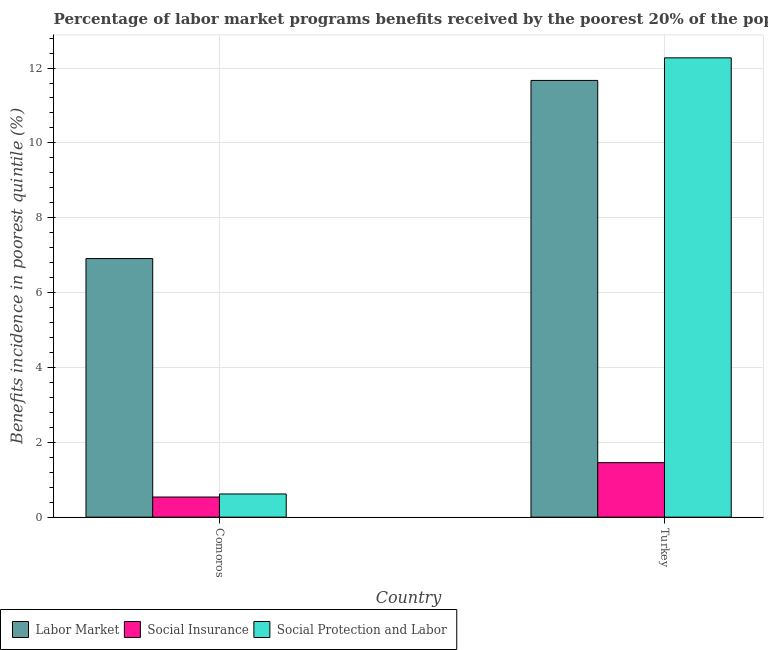How many different coloured bars are there?
Your response must be concise. 3. How many groups of bars are there?
Ensure brevity in your answer.  2. Are the number of bars on each tick of the X-axis equal?
Your response must be concise. Yes. How many bars are there on the 2nd tick from the left?
Your response must be concise. 3. How many bars are there on the 2nd tick from the right?
Keep it short and to the point. 3. What is the label of the 1st group of bars from the left?
Provide a succinct answer. Comoros. In how many cases, is the number of bars for a given country not equal to the number of legend labels?
Provide a short and direct response. 0. What is the percentage of benefits received due to labor market programs in Turkey?
Your response must be concise. 11.67. Across all countries, what is the maximum percentage of benefits received due to social insurance programs?
Make the answer very short. 1.46. Across all countries, what is the minimum percentage of benefits received due to social protection programs?
Your response must be concise. 0.62. In which country was the percentage of benefits received due to labor market programs maximum?
Keep it short and to the point. Turkey. In which country was the percentage of benefits received due to social protection programs minimum?
Provide a short and direct response. Comoros. What is the total percentage of benefits received due to labor market programs in the graph?
Give a very brief answer. 18.58. What is the difference between the percentage of benefits received due to labor market programs in Comoros and that in Turkey?
Offer a terse response. -4.76. What is the difference between the percentage of benefits received due to labor market programs in Comoros and the percentage of benefits received due to social protection programs in Turkey?
Your answer should be very brief. -5.36. What is the average percentage of benefits received due to social insurance programs per country?
Keep it short and to the point. 1. What is the difference between the percentage of benefits received due to social insurance programs and percentage of benefits received due to social protection programs in Comoros?
Offer a terse response. -0.08. What is the ratio of the percentage of benefits received due to social protection programs in Comoros to that in Turkey?
Offer a very short reply. 0.05. In how many countries, is the percentage of benefits received due to social insurance programs greater than the average percentage of benefits received due to social insurance programs taken over all countries?
Your response must be concise. 1. What does the 1st bar from the left in Turkey represents?
Your response must be concise. Labor Market. What does the 3rd bar from the right in Turkey represents?
Offer a terse response. Labor Market. Is it the case that in every country, the sum of the percentage of benefits received due to labor market programs and percentage of benefits received due to social insurance programs is greater than the percentage of benefits received due to social protection programs?
Make the answer very short. Yes. How many countries are there in the graph?
Your response must be concise. 2. Are the values on the major ticks of Y-axis written in scientific E-notation?
Provide a succinct answer. No. Does the graph contain any zero values?
Provide a short and direct response. No. How many legend labels are there?
Ensure brevity in your answer.  3. How are the legend labels stacked?
Ensure brevity in your answer.  Horizontal. What is the title of the graph?
Give a very brief answer. Percentage of labor market programs benefits received by the poorest 20% of the population of countries. Does "Hydroelectric sources" appear as one of the legend labels in the graph?
Your response must be concise. No. What is the label or title of the X-axis?
Make the answer very short. Country. What is the label or title of the Y-axis?
Give a very brief answer. Benefits incidence in poorest quintile (%). What is the Benefits incidence in poorest quintile (%) of Labor Market in Comoros?
Your answer should be very brief. 6.91. What is the Benefits incidence in poorest quintile (%) of Social Insurance in Comoros?
Offer a very short reply. 0.54. What is the Benefits incidence in poorest quintile (%) of Social Protection and Labor in Comoros?
Offer a terse response. 0.62. What is the Benefits incidence in poorest quintile (%) in Labor Market in Turkey?
Your response must be concise. 11.67. What is the Benefits incidence in poorest quintile (%) of Social Insurance in Turkey?
Provide a short and direct response. 1.46. What is the Benefits incidence in poorest quintile (%) of Social Protection and Labor in Turkey?
Ensure brevity in your answer.  12.27. Across all countries, what is the maximum Benefits incidence in poorest quintile (%) in Labor Market?
Ensure brevity in your answer.  11.67. Across all countries, what is the maximum Benefits incidence in poorest quintile (%) in Social Insurance?
Give a very brief answer. 1.46. Across all countries, what is the maximum Benefits incidence in poorest quintile (%) of Social Protection and Labor?
Ensure brevity in your answer.  12.27. Across all countries, what is the minimum Benefits incidence in poorest quintile (%) in Labor Market?
Make the answer very short. 6.91. Across all countries, what is the minimum Benefits incidence in poorest quintile (%) in Social Insurance?
Keep it short and to the point. 0.54. Across all countries, what is the minimum Benefits incidence in poorest quintile (%) in Social Protection and Labor?
Your answer should be very brief. 0.62. What is the total Benefits incidence in poorest quintile (%) of Labor Market in the graph?
Your response must be concise. 18.58. What is the total Benefits incidence in poorest quintile (%) in Social Insurance in the graph?
Your response must be concise. 1.99. What is the total Benefits incidence in poorest quintile (%) of Social Protection and Labor in the graph?
Provide a short and direct response. 12.89. What is the difference between the Benefits incidence in poorest quintile (%) of Labor Market in Comoros and that in Turkey?
Offer a very short reply. -4.76. What is the difference between the Benefits incidence in poorest quintile (%) in Social Insurance in Comoros and that in Turkey?
Offer a very short reply. -0.92. What is the difference between the Benefits incidence in poorest quintile (%) in Social Protection and Labor in Comoros and that in Turkey?
Provide a short and direct response. -11.65. What is the difference between the Benefits incidence in poorest quintile (%) in Labor Market in Comoros and the Benefits incidence in poorest quintile (%) in Social Insurance in Turkey?
Give a very brief answer. 5.45. What is the difference between the Benefits incidence in poorest quintile (%) in Labor Market in Comoros and the Benefits incidence in poorest quintile (%) in Social Protection and Labor in Turkey?
Provide a succinct answer. -5.36. What is the difference between the Benefits incidence in poorest quintile (%) in Social Insurance in Comoros and the Benefits incidence in poorest quintile (%) in Social Protection and Labor in Turkey?
Ensure brevity in your answer.  -11.73. What is the average Benefits incidence in poorest quintile (%) of Labor Market per country?
Provide a succinct answer. 9.29. What is the average Benefits incidence in poorest quintile (%) of Social Protection and Labor per country?
Ensure brevity in your answer.  6.45. What is the difference between the Benefits incidence in poorest quintile (%) in Labor Market and Benefits incidence in poorest quintile (%) in Social Insurance in Comoros?
Offer a very short reply. 6.37. What is the difference between the Benefits incidence in poorest quintile (%) in Labor Market and Benefits incidence in poorest quintile (%) in Social Protection and Labor in Comoros?
Ensure brevity in your answer.  6.29. What is the difference between the Benefits incidence in poorest quintile (%) in Social Insurance and Benefits incidence in poorest quintile (%) in Social Protection and Labor in Comoros?
Provide a short and direct response. -0.08. What is the difference between the Benefits incidence in poorest quintile (%) in Labor Market and Benefits incidence in poorest quintile (%) in Social Insurance in Turkey?
Give a very brief answer. 10.21. What is the difference between the Benefits incidence in poorest quintile (%) of Labor Market and Benefits incidence in poorest quintile (%) of Social Protection and Labor in Turkey?
Provide a short and direct response. -0.6. What is the difference between the Benefits incidence in poorest quintile (%) of Social Insurance and Benefits incidence in poorest quintile (%) of Social Protection and Labor in Turkey?
Make the answer very short. -10.82. What is the ratio of the Benefits incidence in poorest quintile (%) in Labor Market in Comoros to that in Turkey?
Offer a terse response. 0.59. What is the ratio of the Benefits incidence in poorest quintile (%) of Social Insurance in Comoros to that in Turkey?
Your response must be concise. 0.37. What is the ratio of the Benefits incidence in poorest quintile (%) of Social Protection and Labor in Comoros to that in Turkey?
Ensure brevity in your answer.  0.05. What is the difference between the highest and the second highest Benefits incidence in poorest quintile (%) in Labor Market?
Keep it short and to the point. 4.76. What is the difference between the highest and the second highest Benefits incidence in poorest quintile (%) in Social Insurance?
Make the answer very short. 0.92. What is the difference between the highest and the second highest Benefits incidence in poorest quintile (%) of Social Protection and Labor?
Provide a short and direct response. 11.65. What is the difference between the highest and the lowest Benefits incidence in poorest quintile (%) of Labor Market?
Offer a terse response. 4.76. What is the difference between the highest and the lowest Benefits incidence in poorest quintile (%) of Social Insurance?
Your answer should be compact. 0.92. What is the difference between the highest and the lowest Benefits incidence in poorest quintile (%) of Social Protection and Labor?
Offer a very short reply. 11.65. 